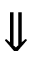Convert formula to latex. <formula><loc_0><loc_0><loc_500><loc_500>\Downarrow</formula> 